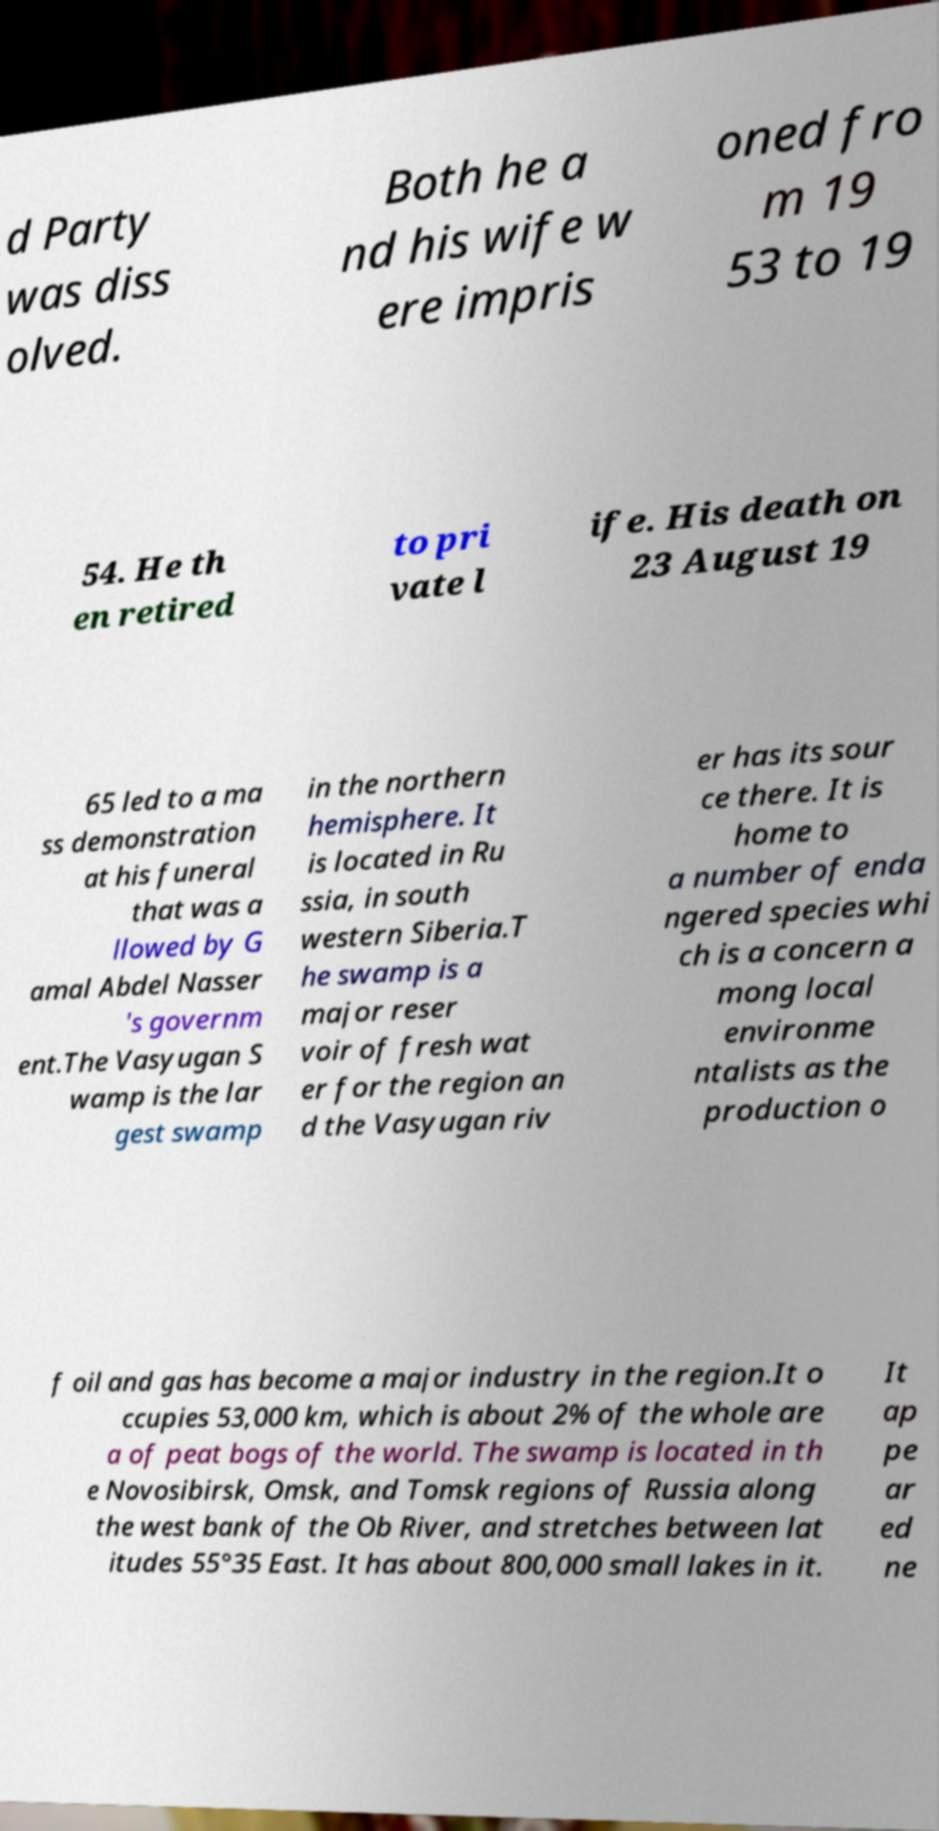Please read and relay the text visible in this image. What does it say? d Party was diss olved. Both he a nd his wife w ere impris oned fro m 19 53 to 19 54. He th en retired to pri vate l ife. His death on 23 August 19 65 led to a ma ss demonstration at his funeral that was a llowed by G amal Abdel Nasser 's governm ent.The Vasyugan S wamp is the lar gest swamp in the northern hemisphere. It is located in Ru ssia, in south western Siberia.T he swamp is a major reser voir of fresh wat er for the region an d the Vasyugan riv er has its sour ce there. It is home to a number of enda ngered species whi ch is a concern a mong local environme ntalists as the production o f oil and gas has become a major industry in the region.It o ccupies 53,000 km, which is about 2% of the whole are a of peat bogs of the world. The swamp is located in th e Novosibirsk, Omsk, and Tomsk regions of Russia along the west bank of the Ob River, and stretches between lat itudes 55°35 East. It has about 800,000 small lakes in it. It ap pe ar ed ne 